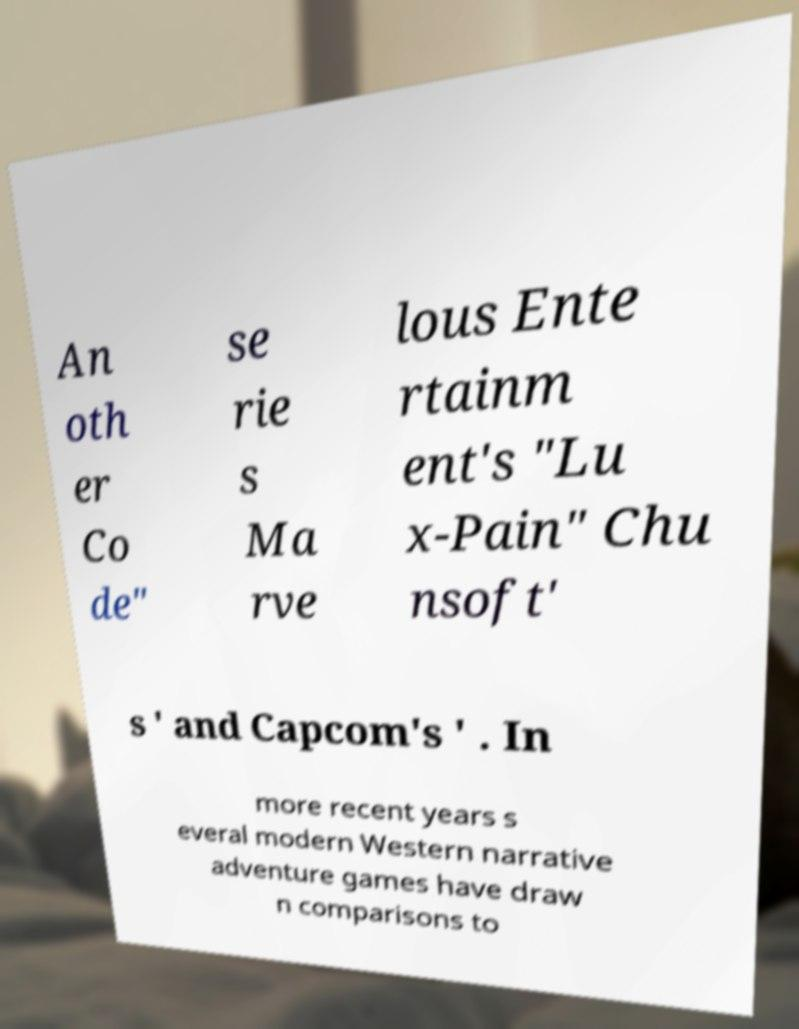Please identify and transcribe the text found in this image. An oth er Co de" se rie s Ma rve lous Ente rtainm ent's "Lu x-Pain" Chu nsoft' s ' and Capcom's ' . In more recent years s everal modern Western narrative adventure games have draw n comparisons to 